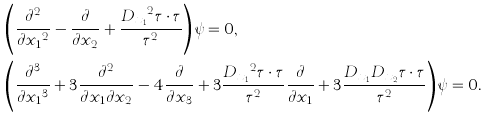Convert formula to latex. <formula><loc_0><loc_0><loc_500><loc_500>& \left ( \frac { \partial ^ { 2 } } { \partial { x _ { 1 } } ^ { 2 } } - \frac { \partial } { \partial x _ { 2 } } + \frac { { D _ { x _ { 1 } } } ^ { 2 } \tau \cdot \tau } { \tau ^ { 2 } } \right ) \psi = 0 , \\ & \left ( \frac { \partial ^ { 3 } } { \partial { x _ { 1 } } ^ { 3 } } + 3 \frac { \partial ^ { 2 } } { \partial x _ { 1 } \partial x _ { 2 } } - 4 \frac { \partial } { \partial x _ { 3 } } + 3 \frac { { D _ { x _ { 1 } } } ^ { 2 } \tau \cdot \tau } { \tau ^ { 2 } } \frac { \partial } { \partial x _ { 1 } } + 3 \frac { D _ { x _ { 1 } } D _ { x _ { 2 } } \tau \cdot \tau } { \tau ^ { 2 } } \right ) \psi = 0 .</formula> 